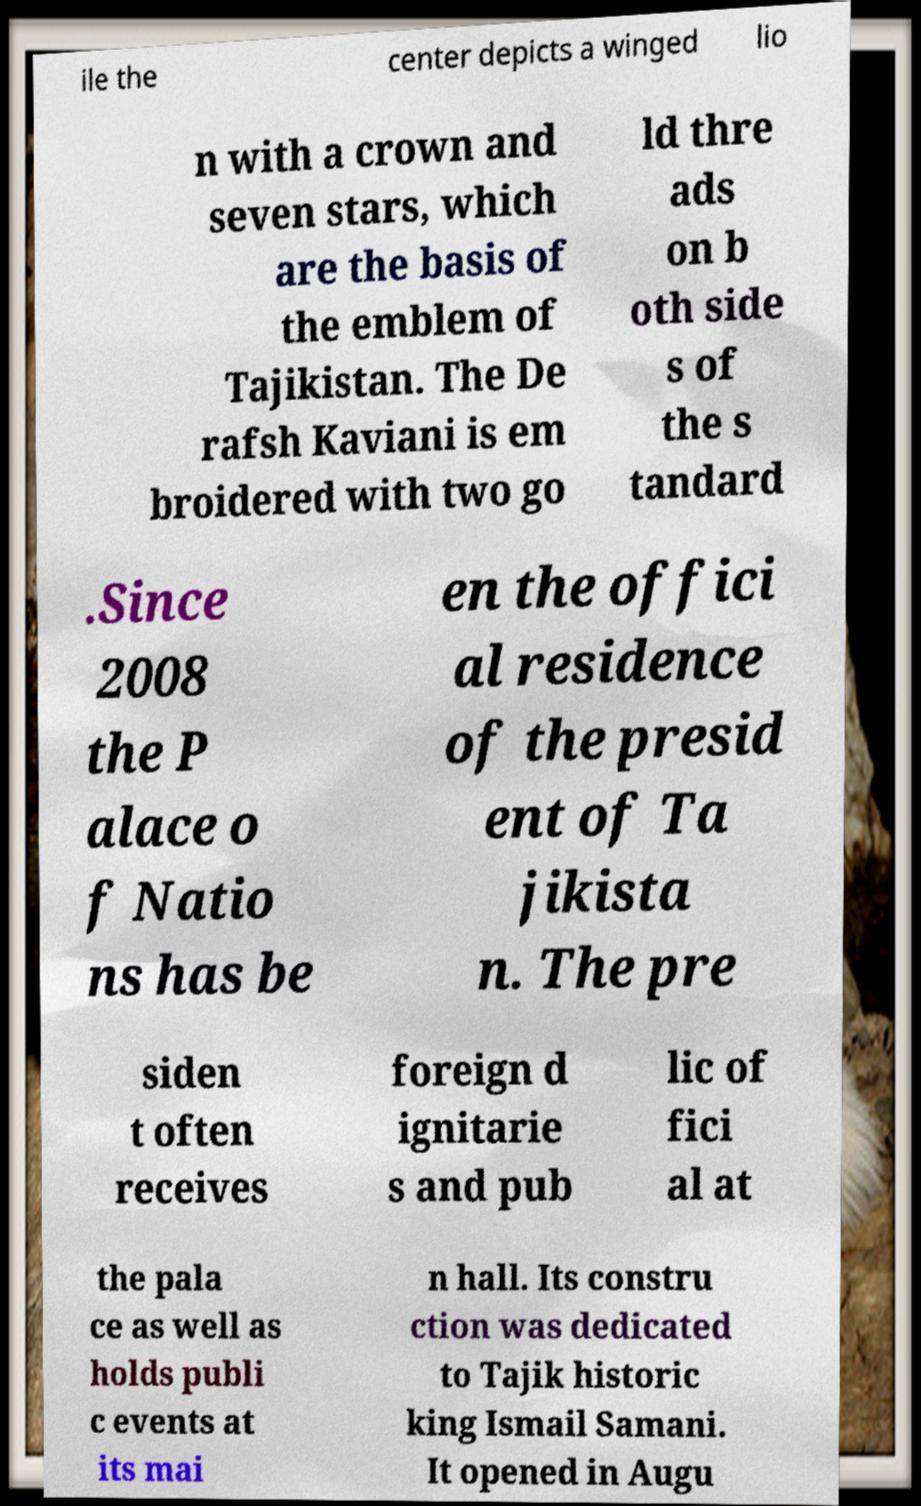Could you assist in decoding the text presented in this image and type it out clearly? ile the center depicts a winged lio n with a crown and seven stars, which are the basis of the emblem of Tajikistan. The De rafsh Kaviani is em broidered with two go ld thre ads on b oth side s of the s tandard .Since 2008 the P alace o f Natio ns has be en the offici al residence of the presid ent of Ta jikista n. The pre siden t often receives foreign d ignitarie s and pub lic of fici al at the pala ce as well as holds publi c events at its mai n hall. Its constru ction was dedicated to Tajik historic king Ismail Samani. It opened in Augu 